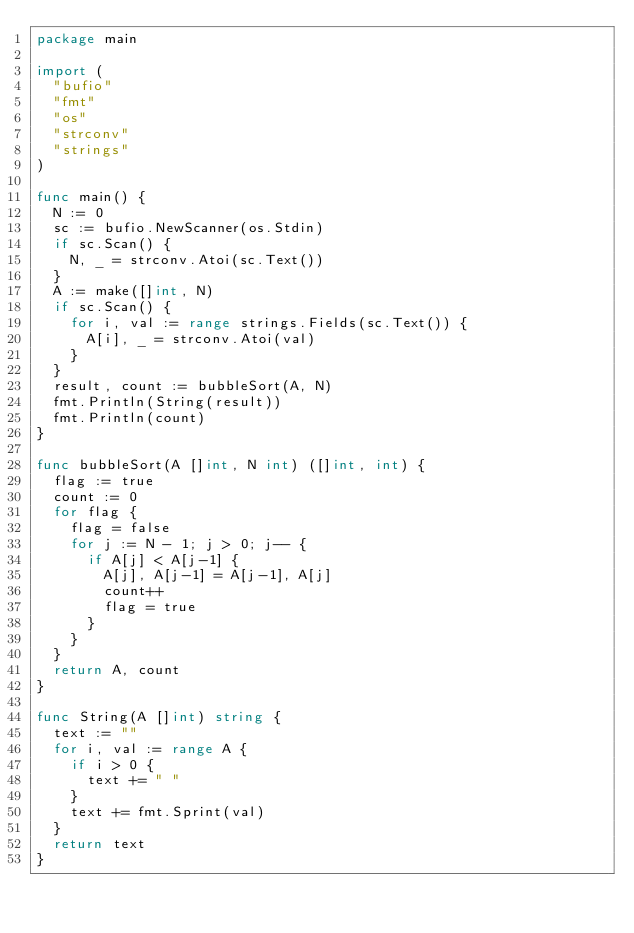Convert code to text. <code><loc_0><loc_0><loc_500><loc_500><_Go_>package main

import (
	"bufio"
	"fmt"
	"os"
	"strconv"
	"strings"
)

func main() {
	N := 0
	sc := bufio.NewScanner(os.Stdin)
	if sc.Scan() {
		N, _ = strconv.Atoi(sc.Text())
	}
	A := make([]int, N)
	if sc.Scan() {
		for i, val := range strings.Fields(sc.Text()) {
			A[i], _ = strconv.Atoi(val)
		}
	}
	result, count := bubbleSort(A, N)
	fmt.Println(String(result))
	fmt.Println(count)
}

func bubbleSort(A []int, N int) ([]int, int) {
	flag := true
	count := 0
	for flag {
		flag = false
		for j := N - 1; j > 0; j-- {
			if A[j] < A[j-1] {
				A[j], A[j-1] = A[j-1], A[j]
				count++
				flag = true
			}
		}
	}
	return A, count
}

func String(A []int) string {
	text := ""
	for i, val := range A {
		if i > 0 {
			text += " "
		}
		text += fmt.Sprint(val)
	}
	return text
}

</code> 